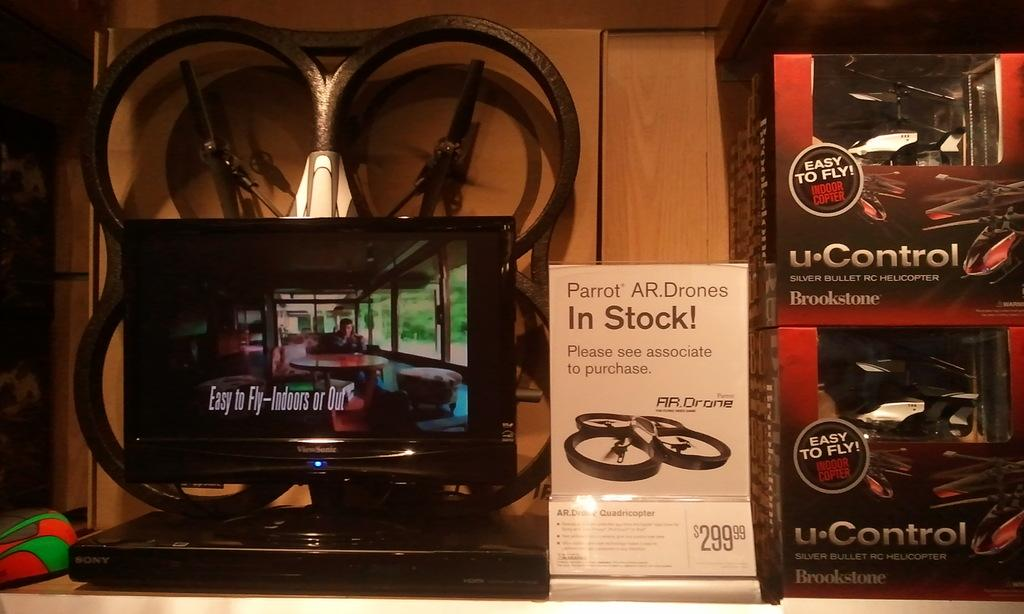<image>
Offer a succinct explanation of the picture presented. A bicycle shop window with a display of parts and a sign about wheels in stock. 